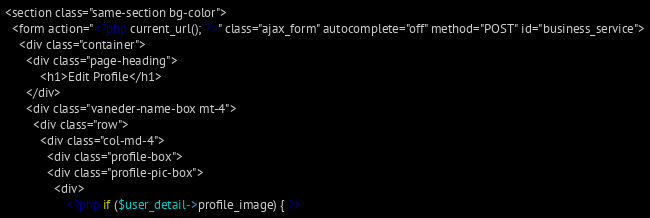Convert code to text. <code><loc_0><loc_0><loc_500><loc_500><_PHP_><section class="same-section bg-color">
  <form action="<?php current_url(); ?>" class="ajax_form" autocomplete="off" method="POST" id="business_service">
    <div class="container">
      <div class="page-heading">
          <h1>Edit Profile</h1>
      </div>
      <div class="vaneder-name-box mt-4">
        <div class="row">
          <div class="col-md-4">
            <div class="profile-box">
            <div class="profile-pic-box">
              <div>
                  <?php if ($user_detail->profile_image) { ?></code> 